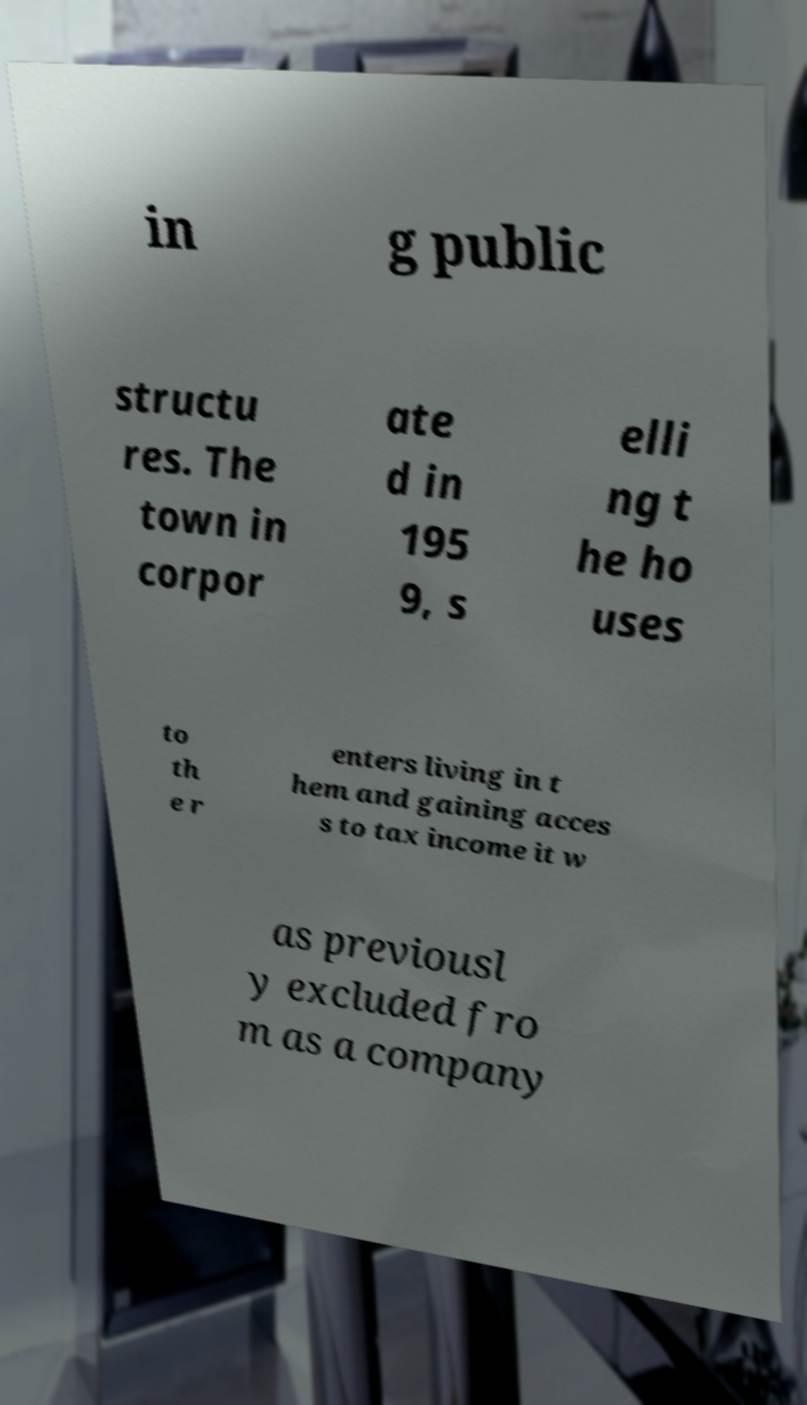There's text embedded in this image that I need extracted. Can you transcribe it verbatim? in g public structu res. The town in corpor ate d in 195 9, s elli ng t he ho uses to th e r enters living in t hem and gaining acces s to tax income it w as previousl y excluded fro m as a company 